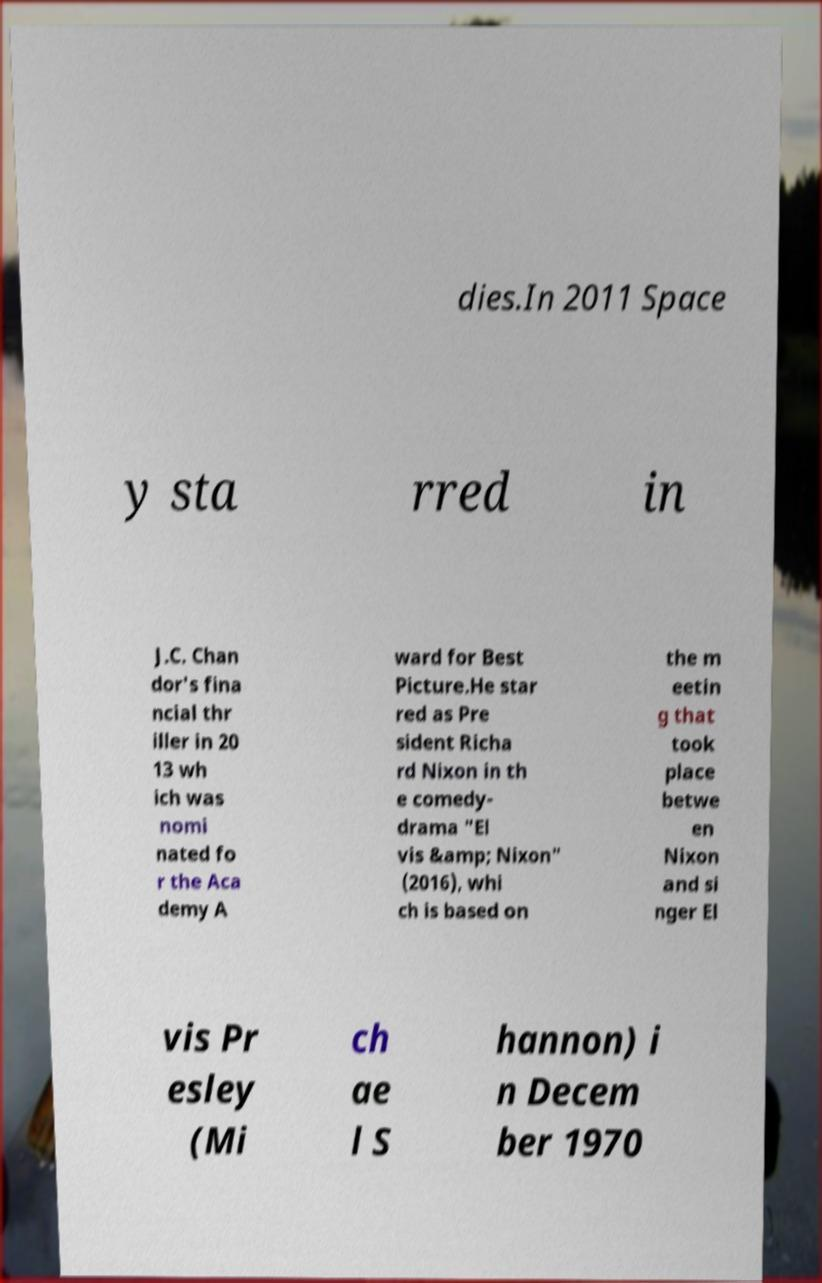Can you accurately transcribe the text from the provided image for me? dies.In 2011 Space y sta rred in J.C. Chan dor's fina ncial thr iller in 20 13 wh ich was nomi nated fo r the Aca demy A ward for Best Picture.He star red as Pre sident Richa rd Nixon in th e comedy- drama "El vis &amp; Nixon" (2016), whi ch is based on the m eetin g that took place betwe en Nixon and si nger El vis Pr esley (Mi ch ae l S hannon) i n Decem ber 1970 